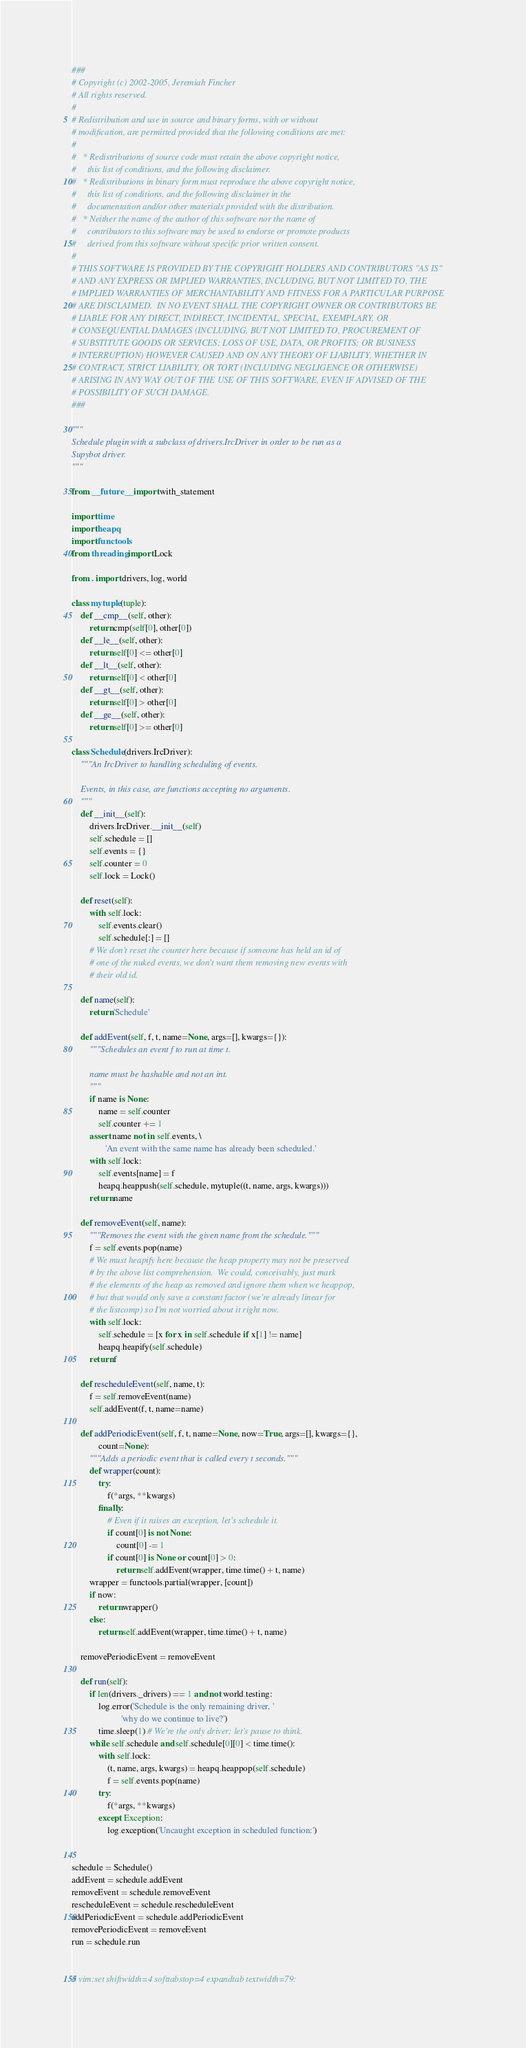<code> <loc_0><loc_0><loc_500><loc_500><_Python_>###
# Copyright (c) 2002-2005, Jeremiah Fincher
# All rights reserved.
#
# Redistribution and use in source and binary forms, with or without
# modification, are permitted provided that the following conditions are met:
#
#   * Redistributions of source code must retain the above copyright notice,
#     this list of conditions, and the following disclaimer.
#   * Redistributions in binary form must reproduce the above copyright notice,
#     this list of conditions, and the following disclaimer in the
#     documentation and/or other materials provided with the distribution.
#   * Neither the name of the author of this software nor the name of
#     contributors to this software may be used to endorse or promote products
#     derived from this software without specific prior written consent.
#
# THIS SOFTWARE IS PROVIDED BY THE COPYRIGHT HOLDERS AND CONTRIBUTORS "AS IS"
# AND ANY EXPRESS OR IMPLIED WARRANTIES, INCLUDING, BUT NOT LIMITED TO, THE
# IMPLIED WARRANTIES OF MERCHANTABILITY AND FITNESS FOR A PARTICULAR PURPOSE
# ARE DISCLAIMED.  IN NO EVENT SHALL THE COPYRIGHT OWNER OR CONTRIBUTORS BE
# LIABLE FOR ANY DIRECT, INDIRECT, INCIDENTAL, SPECIAL, EXEMPLARY, OR
# CONSEQUENTIAL DAMAGES (INCLUDING, BUT NOT LIMITED TO, PROCUREMENT OF
# SUBSTITUTE GOODS OR SERVICES; LOSS OF USE, DATA, OR PROFITS; OR BUSINESS
# INTERRUPTION) HOWEVER CAUSED AND ON ANY THEORY OF LIABILITY, WHETHER IN
# CONTRACT, STRICT LIABILITY, OR TORT (INCLUDING NEGLIGENCE OR OTHERWISE)
# ARISING IN ANY WAY OUT OF THE USE OF THIS SOFTWARE, EVEN IF ADVISED OF THE
# POSSIBILITY OF SUCH DAMAGE.
###

"""
Schedule plugin with a subclass of drivers.IrcDriver in order to be run as a
Supybot driver.
"""

from __future__ import with_statement

import time
import heapq
import functools
from threading import Lock

from . import drivers, log, world

class mytuple(tuple):
    def __cmp__(self, other):
        return cmp(self[0], other[0])
    def __le__(self, other):
        return self[0] <= other[0]
    def __lt__(self, other):
        return self[0] < other[0]
    def __gt__(self, other):
        return self[0] > other[0]
    def __ge__(self, other):
        return self[0] >= other[0]

class Schedule(drivers.IrcDriver):
    """An IrcDriver to handling scheduling of events.

    Events, in this case, are functions accepting no arguments.
    """
    def __init__(self):
        drivers.IrcDriver.__init__(self)
        self.schedule = []
        self.events = {}
        self.counter = 0
        self.lock = Lock()

    def reset(self):
        with self.lock:
            self.events.clear()
            self.schedule[:] = []
        # We don't reset the counter here because if someone has held an id of
        # one of the nuked events, we don't want them removing new events with
        # their old id.

    def name(self):
        return 'Schedule'

    def addEvent(self, f, t, name=None, args=[], kwargs={}):
        """Schedules an event f to run at time t.

        name must be hashable and not an int.
        """
        if name is None:
            name = self.counter
            self.counter += 1
        assert name not in self.events, \
               'An event with the same name has already been scheduled.'
        with self.lock:
            self.events[name] = f
            heapq.heappush(self.schedule, mytuple((t, name, args, kwargs)))
        return name

    def removeEvent(self, name):
        """Removes the event with the given name from the schedule."""
        f = self.events.pop(name)
        # We must heapify here because the heap property may not be preserved
        # by the above list comprehension.  We could, conceivably, just mark
        # the elements of the heap as removed and ignore them when we heappop,
        # but that would only save a constant factor (we're already linear for
        # the listcomp) so I'm not worried about it right now.
        with self.lock:
            self.schedule = [x for x in self.schedule if x[1] != name]
            heapq.heapify(self.schedule)
        return f

    def rescheduleEvent(self, name, t):
        f = self.removeEvent(name)
        self.addEvent(f, t, name=name)

    def addPeriodicEvent(self, f, t, name=None, now=True, args=[], kwargs={},
            count=None):
        """Adds a periodic event that is called every t seconds."""
        def wrapper(count):
            try:
                f(*args, **kwargs)
            finally:
                # Even if it raises an exception, let's schedule it.
                if count[0] is not None:
                    count[0] -= 1
                if count[0] is None or count[0] > 0:
                    return self.addEvent(wrapper, time.time() + t, name)
        wrapper = functools.partial(wrapper, [count])
        if now:
            return wrapper()
        else:
            return self.addEvent(wrapper, time.time() + t, name)

    removePeriodicEvent = removeEvent

    def run(self):
        if len(drivers._drivers) == 1 and not world.testing:
            log.error('Schedule is the only remaining driver, '
                      'why do we continue to live?')
            time.sleep(1) # We're the only driver; let's pause to think.
        while self.schedule and self.schedule[0][0] < time.time():
            with self.lock:
                (t, name, args, kwargs) = heapq.heappop(self.schedule)
                f = self.events.pop(name)
            try:
                f(*args, **kwargs)
            except Exception:
                log.exception('Uncaught exception in scheduled function:')


schedule = Schedule()
addEvent = schedule.addEvent
removeEvent = schedule.removeEvent
rescheduleEvent = schedule.rescheduleEvent
addPeriodicEvent = schedule.addPeriodicEvent
removePeriodicEvent = removeEvent
run = schedule.run


# vim:set shiftwidth=4 softtabstop=4 expandtab textwidth=79:
</code> 